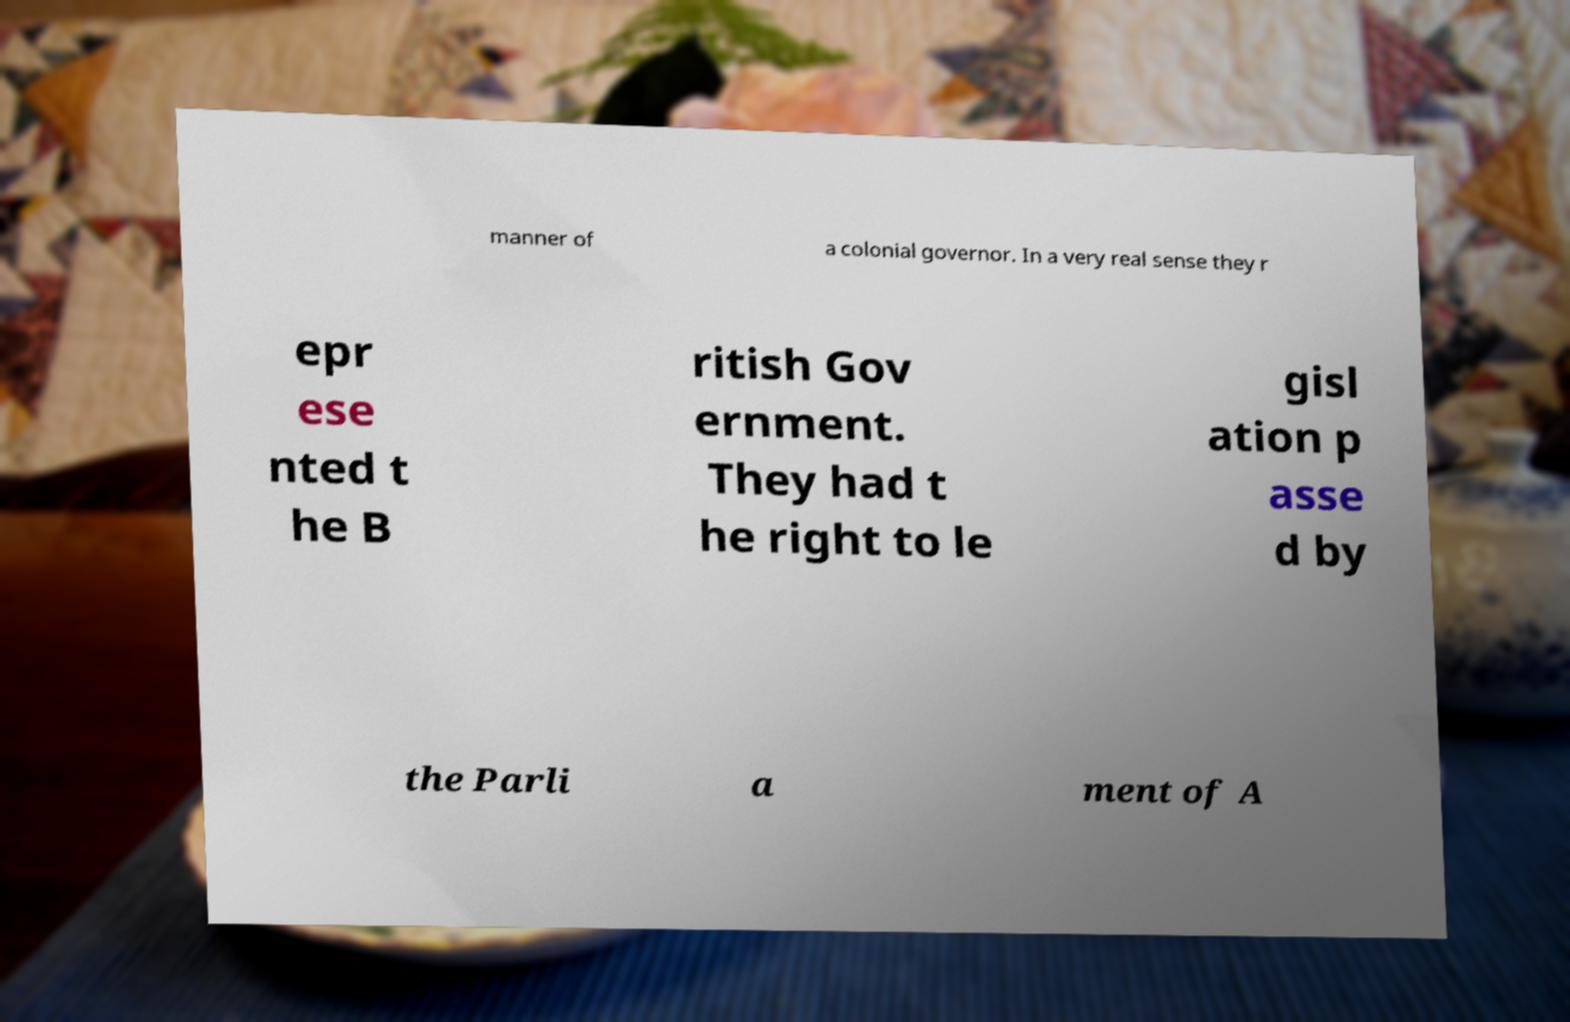Please identify and transcribe the text found in this image. manner of a colonial governor. In a very real sense they r epr ese nted t he B ritish Gov ernment. They had t he right to le gisl ation p asse d by the Parli a ment of A 